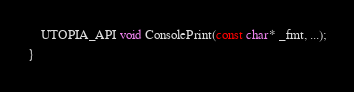<code> <loc_0><loc_0><loc_500><loc_500><_C_>	UTOPIA_API void ConsolePrint(const char* _fmt, ...);
}</code> 